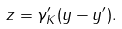Convert formula to latex. <formula><loc_0><loc_0><loc_500><loc_500>z = \gamma _ { K } ^ { \prime } ( y - y ^ { \prime } ) .</formula> 